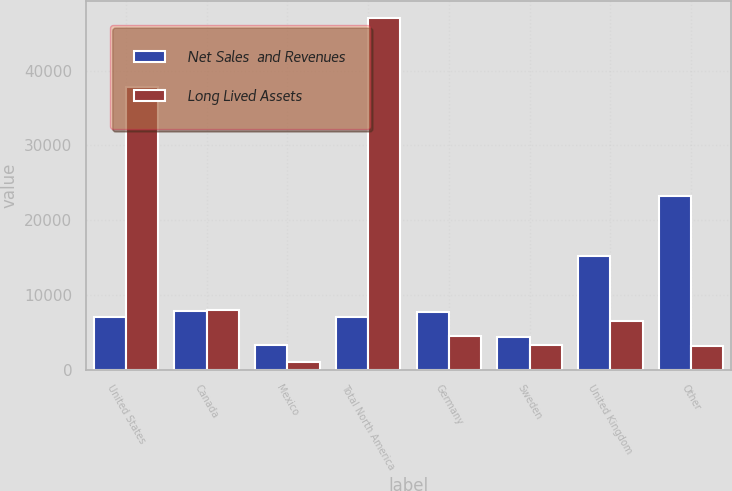Convert chart. <chart><loc_0><loc_0><loc_500><loc_500><stacked_bar_chart><ecel><fcel>United States<fcel>Canada<fcel>Mexico<fcel>Total North America<fcel>Germany<fcel>Sweden<fcel>United Kingdom<fcel>Other<nl><fcel>Net Sales  and Revenues<fcel>7119<fcel>7945<fcel>3399<fcel>7119<fcel>7701<fcel>4412<fcel>15287<fcel>23221<nl><fcel>Long Lived Assets<fcel>37830<fcel>8062<fcel>1073<fcel>46965<fcel>4518<fcel>3399<fcel>6537<fcel>3172<nl></chart> 